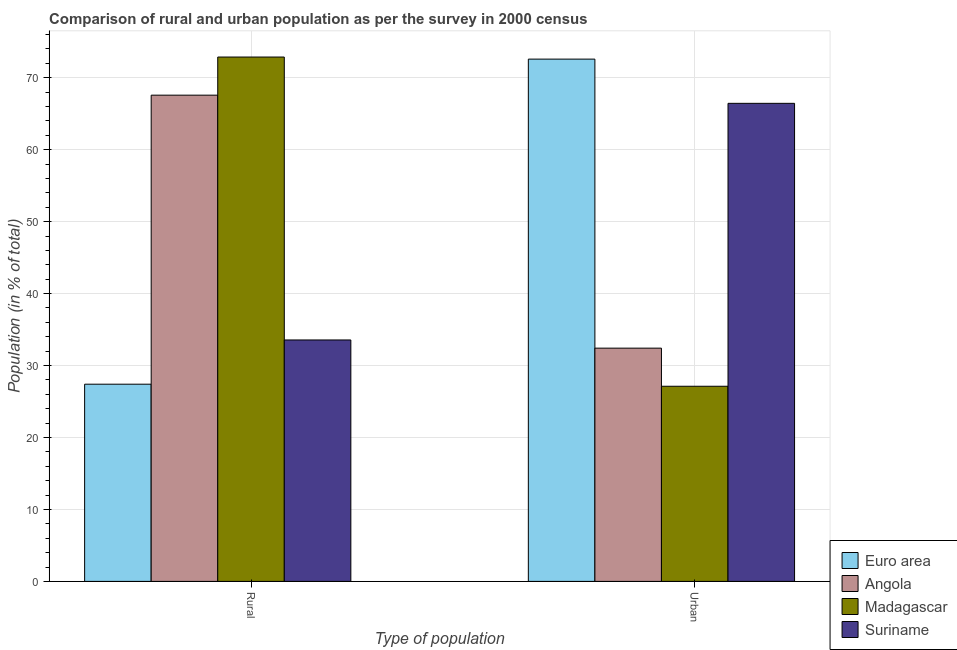How many groups of bars are there?
Offer a terse response. 2. Are the number of bars on each tick of the X-axis equal?
Offer a terse response. Yes. How many bars are there on the 1st tick from the left?
Provide a succinct answer. 4. How many bars are there on the 2nd tick from the right?
Offer a very short reply. 4. What is the label of the 2nd group of bars from the left?
Give a very brief answer. Urban. What is the urban population in Madagascar?
Keep it short and to the point. 27.12. Across all countries, what is the maximum urban population?
Your response must be concise. 72.59. Across all countries, what is the minimum rural population?
Ensure brevity in your answer.  27.41. In which country was the urban population maximum?
Offer a terse response. Euro area. In which country was the urban population minimum?
Ensure brevity in your answer.  Madagascar. What is the total rural population in the graph?
Give a very brief answer. 201.42. What is the difference between the rural population in Angola and that in Suriname?
Your answer should be compact. 34.03. What is the difference between the rural population in Euro area and the urban population in Madagascar?
Provide a short and direct response. 0.29. What is the average rural population per country?
Your response must be concise. 50.36. What is the difference between the urban population and rural population in Euro area?
Provide a short and direct response. 45.18. What is the ratio of the urban population in Euro area to that in Angola?
Provide a short and direct response. 2.24. What does the 3rd bar from the right in Rural represents?
Ensure brevity in your answer.  Angola. Are all the bars in the graph horizontal?
Your answer should be compact. No. Are the values on the major ticks of Y-axis written in scientific E-notation?
Offer a very short reply. No. What is the title of the graph?
Your response must be concise. Comparison of rural and urban population as per the survey in 2000 census. Does "Vanuatu" appear as one of the legend labels in the graph?
Your answer should be compact. No. What is the label or title of the X-axis?
Offer a very short reply. Type of population. What is the label or title of the Y-axis?
Provide a succinct answer. Population (in % of total). What is the Population (in % of total) in Euro area in Rural?
Keep it short and to the point. 27.41. What is the Population (in % of total) in Angola in Rural?
Provide a short and direct response. 67.58. What is the Population (in % of total) in Madagascar in Rural?
Ensure brevity in your answer.  72.88. What is the Population (in % of total) in Suriname in Rural?
Your answer should be compact. 33.56. What is the Population (in % of total) of Euro area in Urban?
Provide a short and direct response. 72.59. What is the Population (in % of total) of Angola in Urban?
Offer a very short reply. 32.42. What is the Population (in % of total) of Madagascar in Urban?
Keep it short and to the point. 27.12. What is the Population (in % of total) in Suriname in Urban?
Your answer should be compact. 66.44. Across all Type of population, what is the maximum Population (in % of total) of Euro area?
Keep it short and to the point. 72.59. Across all Type of population, what is the maximum Population (in % of total) in Angola?
Make the answer very short. 67.58. Across all Type of population, what is the maximum Population (in % of total) of Madagascar?
Give a very brief answer. 72.88. Across all Type of population, what is the maximum Population (in % of total) in Suriname?
Keep it short and to the point. 66.44. Across all Type of population, what is the minimum Population (in % of total) in Euro area?
Ensure brevity in your answer.  27.41. Across all Type of population, what is the minimum Population (in % of total) in Angola?
Offer a very short reply. 32.42. Across all Type of population, what is the minimum Population (in % of total) of Madagascar?
Your answer should be very brief. 27.12. Across all Type of population, what is the minimum Population (in % of total) in Suriname?
Provide a succinct answer. 33.56. What is the total Population (in % of total) of Euro area in the graph?
Provide a short and direct response. 100. What is the total Population (in % of total) in Angola in the graph?
Provide a succinct answer. 100. What is the total Population (in % of total) in Madagascar in the graph?
Your response must be concise. 100. What is the difference between the Population (in % of total) in Euro area in Rural and that in Urban?
Make the answer very short. -45.18. What is the difference between the Population (in % of total) in Angola in Rural and that in Urban?
Ensure brevity in your answer.  35.16. What is the difference between the Population (in % of total) in Madagascar in Rural and that in Urban?
Offer a very short reply. 45.76. What is the difference between the Population (in % of total) in Suriname in Rural and that in Urban?
Offer a very short reply. -32.89. What is the difference between the Population (in % of total) in Euro area in Rural and the Population (in % of total) in Angola in Urban?
Make the answer very short. -5.01. What is the difference between the Population (in % of total) in Euro area in Rural and the Population (in % of total) in Madagascar in Urban?
Ensure brevity in your answer.  0.29. What is the difference between the Population (in % of total) of Euro area in Rural and the Population (in % of total) of Suriname in Urban?
Keep it short and to the point. -39.04. What is the difference between the Population (in % of total) of Angola in Rural and the Population (in % of total) of Madagascar in Urban?
Make the answer very short. 40.46. What is the difference between the Population (in % of total) of Angola in Rural and the Population (in % of total) of Suriname in Urban?
Your answer should be compact. 1.14. What is the difference between the Population (in % of total) in Madagascar in Rural and the Population (in % of total) in Suriname in Urban?
Your response must be concise. 6.43. What is the average Population (in % of total) in Euro area per Type of population?
Your answer should be very brief. 50. What is the average Population (in % of total) in Angola per Type of population?
Your answer should be compact. 50. What is the average Population (in % of total) of Madagascar per Type of population?
Your answer should be compact. 50. What is the average Population (in % of total) of Suriname per Type of population?
Provide a short and direct response. 50. What is the difference between the Population (in % of total) of Euro area and Population (in % of total) of Angola in Rural?
Offer a very short reply. -40.17. What is the difference between the Population (in % of total) in Euro area and Population (in % of total) in Madagascar in Rural?
Provide a short and direct response. -45.47. What is the difference between the Population (in % of total) of Euro area and Population (in % of total) of Suriname in Rural?
Give a very brief answer. -6.15. What is the difference between the Population (in % of total) of Angola and Population (in % of total) of Madagascar in Rural?
Give a very brief answer. -5.3. What is the difference between the Population (in % of total) of Angola and Population (in % of total) of Suriname in Rural?
Keep it short and to the point. 34.02. What is the difference between the Population (in % of total) of Madagascar and Population (in % of total) of Suriname in Rural?
Provide a succinct answer. 39.32. What is the difference between the Population (in % of total) of Euro area and Population (in % of total) of Angola in Urban?
Offer a terse response. 40.17. What is the difference between the Population (in % of total) of Euro area and Population (in % of total) of Madagascar in Urban?
Your response must be concise. 45.47. What is the difference between the Population (in % of total) of Euro area and Population (in % of total) of Suriname in Urban?
Give a very brief answer. 6.15. What is the difference between the Population (in % of total) of Angola and Population (in % of total) of Madagascar in Urban?
Ensure brevity in your answer.  5.3. What is the difference between the Population (in % of total) of Angola and Population (in % of total) of Suriname in Urban?
Offer a terse response. -34.02. What is the difference between the Population (in % of total) of Madagascar and Population (in % of total) of Suriname in Urban?
Keep it short and to the point. -39.32. What is the ratio of the Population (in % of total) of Euro area in Rural to that in Urban?
Give a very brief answer. 0.38. What is the ratio of the Population (in % of total) of Angola in Rural to that in Urban?
Keep it short and to the point. 2.08. What is the ratio of the Population (in % of total) of Madagascar in Rural to that in Urban?
Make the answer very short. 2.69. What is the ratio of the Population (in % of total) in Suriname in Rural to that in Urban?
Ensure brevity in your answer.  0.51. What is the difference between the highest and the second highest Population (in % of total) in Euro area?
Your answer should be very brief. 45.18. What is the difference between the highest and the second highest Population (in % of total) of Angola?
Make the answer very short. 35.16. What is the difference between the highest and the second highest Population (in % of total) of Madagascar?
Ensure brevity in your answer.  45.76. What is the difference between the highest and the second highest Population (in % of total) of Suriname?
Give a very brief answer. 32.89. What is the difference between the highest and the lowest Population (in % of total) of Euro area?
Ensure brevity in your answer.  45.18. What is the difference between the highest and the lowest Population (in % of total) in Angola?
Ensure brevity in your answer.  35.16. What is the difference between the highest and the lowest Population (in % of total) of Madagascar?
Your answer should be compact. 45.76. What is the difference between the highest and the lowest Population (in % of total) of Suriname?
Offer a very short reply. 32.89. 